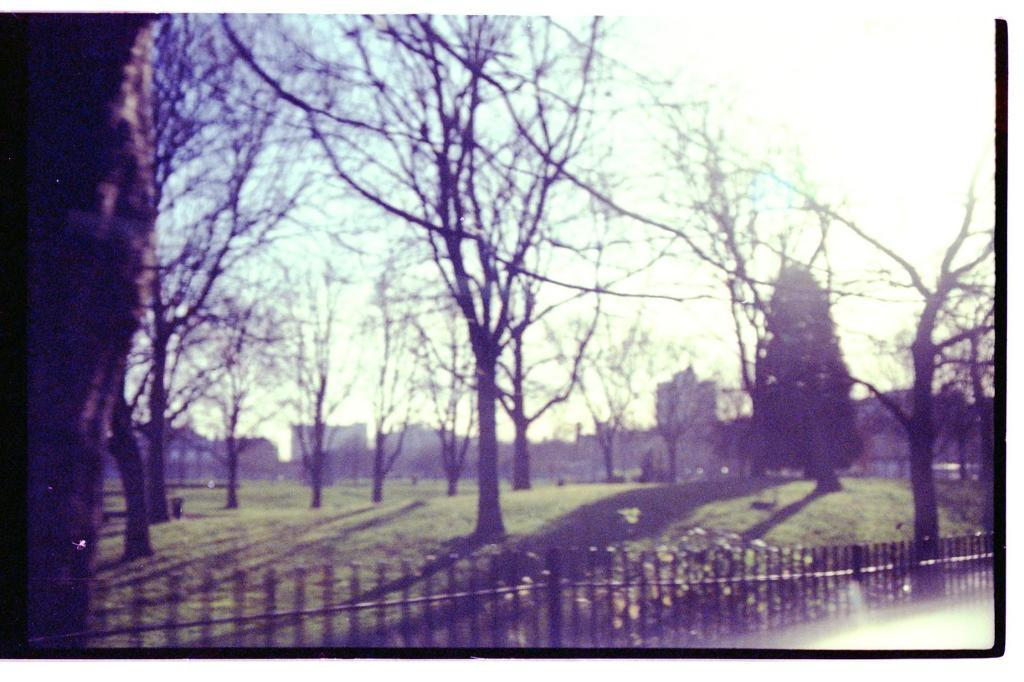What type of natural elements can be seen in the image? There are trees in the image. What type of man-made structures are present in the image? There are buildings in the image. What type of barrier can be seen in the image? There is a metal fence in the image. What type of noise can be heard coming from the railway in the image? There is no railway present in the image, so it's not possible to determine what, if any, noise might be heard. 